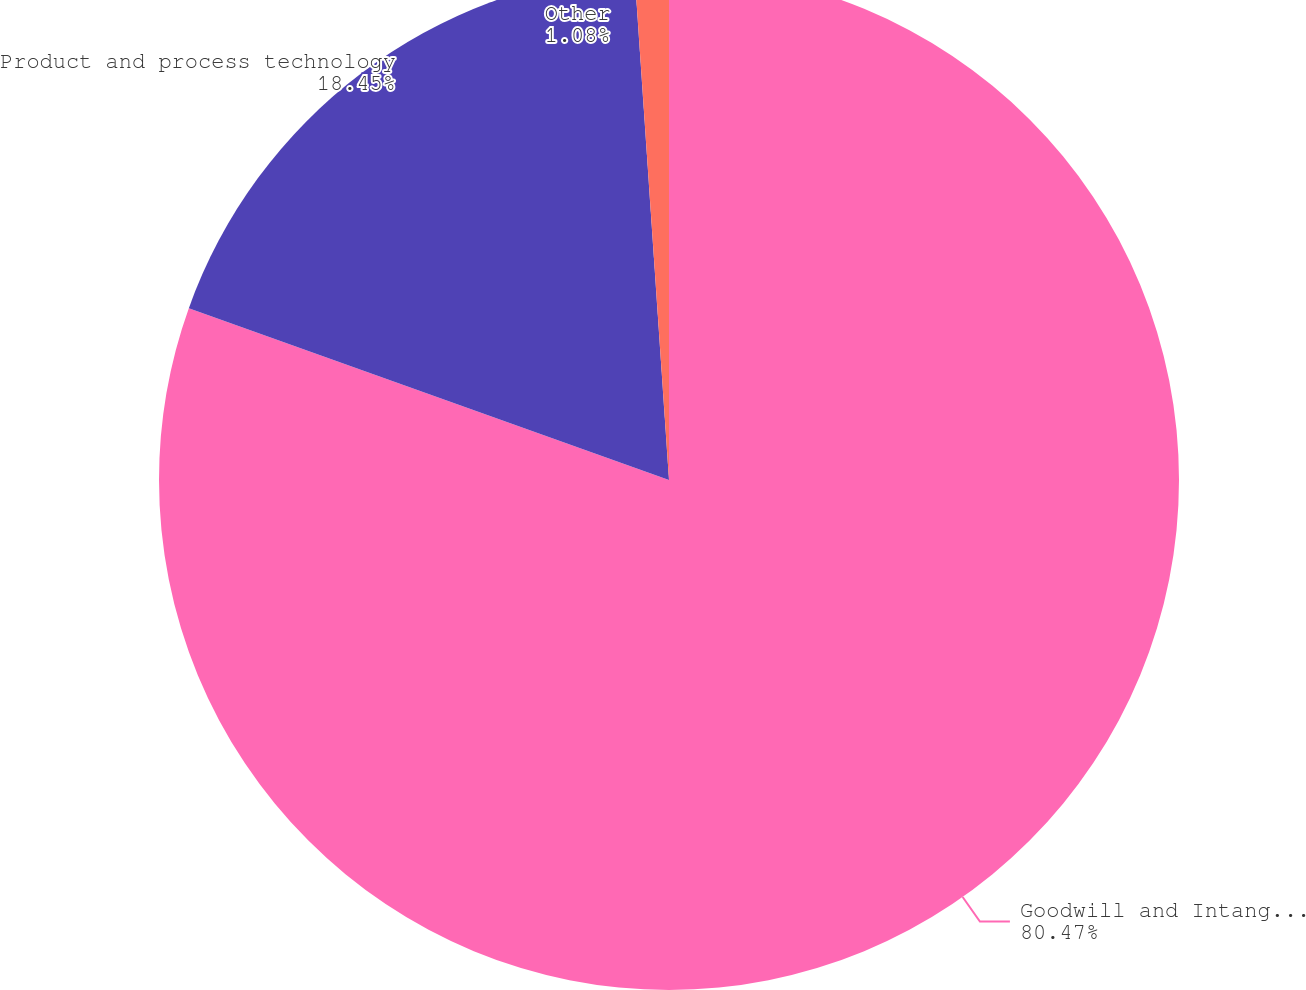Convert chart. <chart><loc_0><loc_0><loc_500><loc_500><pie_chart><fcel>Goodwill and Intangible Assets<fcel>Product and process technology<fcel>Other<nl><fcel>80.47%<fcel>18.45%<fcel>1.08%<nl></chart> 